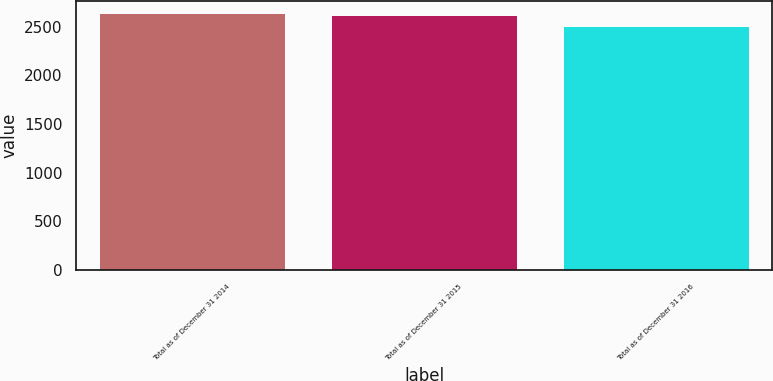Convert chart. <chart><loc_0><loc_0><loc_500><loc_500><bar_chart><fcel>Total as of December 31 2014<fcel>Total as of December 31 2015<fcel>Total as of December 31 2016<nl><fcel>2637<fcel>2622<fcel>2503<nl></chart> 